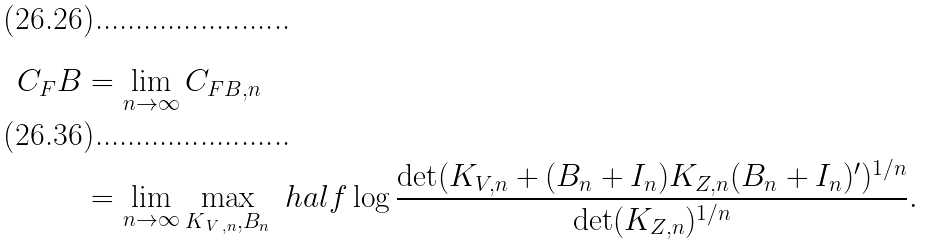<formula> <loc_0><loc_0><loc_500><loc_500>C _ { F } B & = \lim _ { n \to \infty } C _ { F B , n } \\ & = \lim _ { n \to \infty } \max _ { K _ { \, V \, , n } , B _ { n } } \ h a l f \log \frac { \det ( K _ { V , n } + ( B _ { n } + I _ { n } ) K _ { Z , n } ( B _ { n } + I _ { n } ) ^ { \prime } ) ^ { 1 / n } } { \det ( K _ { Z , n } ) ^ { 1 / n } } .</formula> 